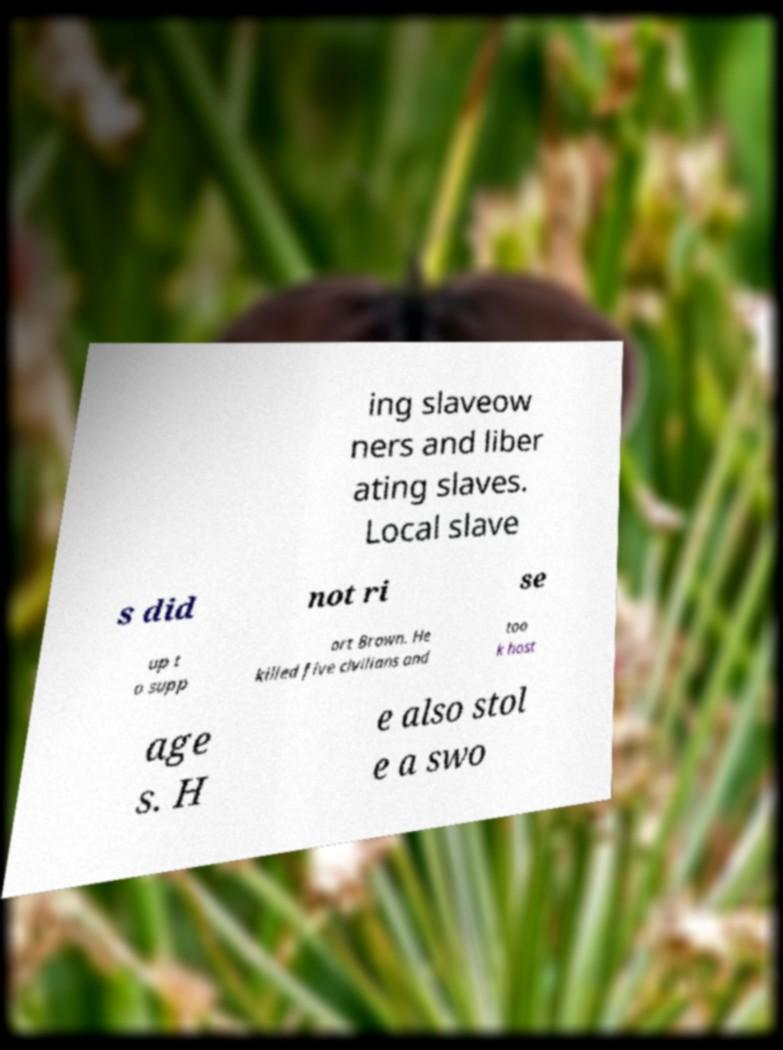Can you accurately transcribe the text from the provided image for me? ing slaveow ners and liber ating slaves. Local slave s did not ri se up t o supp ort Brown. He killed five civilians and too k host age s. H e also stol e a swo 